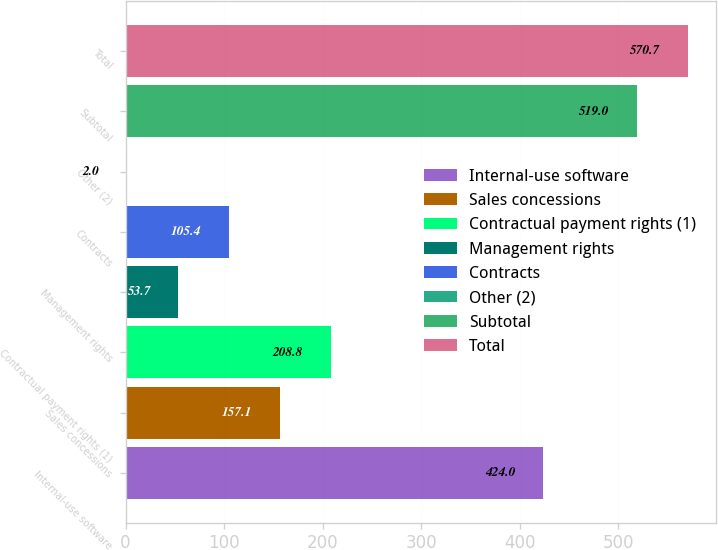Convert chart to OTSL. <chart><loc_0><loc_0><loc_500><loc_500><bar_chart><fcel>Internal-use software<fcel>Sales concessions<fcel>Contractual payment rights (1)<fcel>Management rights<fcel>Contracts<fcel>Other (2)<fcel>Subtotal<fcel>Total<nl><fcel>424<fcel>157.1<fcel>208.8<fcel>53.7<fcel>105.4<fcel>2<fcel>519<fcel>570.7<nl></chart> 